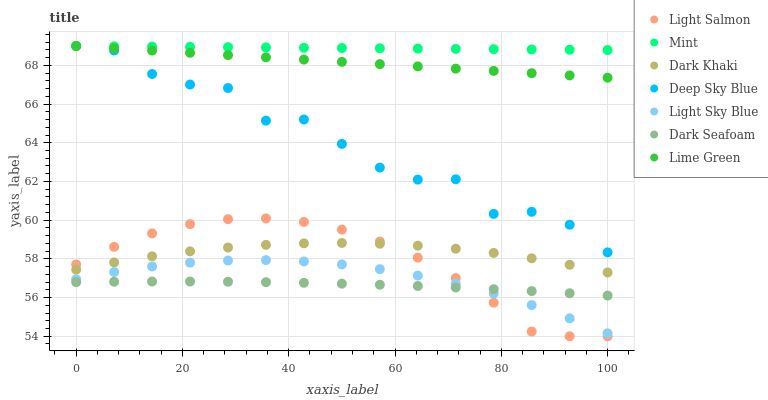Does Dark Seafoam have the minimum area under the curve?
Answer yes or no. Yes. Does Mint have the maximum area under the curve?
Answer yes or no. Yes. Does Lime Green have the minimum area under the curve?
Answer yes or no. No. Does Lime Green have the maximum area under the curve?
Answer yes or no. No. Is Mint the smoothest?
Answer yes or no. Yes. Is Deep Sky Blue the roughest?
Answer yes or no. Yes. Is Lime Green the smoothest?
Answer yes or no. No. Is Lime Green the roughest?
Answer yes or no. No. Does Light Salmon have the lowest value?
Answer yes or no. Yes. Does Lime Green have the lowest value?
Answer yes or no. No. Does Mint have the highest value?
Answer yes or no. Yes. Does Dark Khaki have the highest value?
Answer yes or no. No. Is Light Sky Blue less than Deep Sky Blue?
Answer yes or no. Yes. Is Lime Green greater than Dark Seafoam?
Answer yes or no. Yes. Does Light Salmon intersect Dark Seafoam?
Answer yes or no. Yes. Is Light Salmon less than Dark Seafoam?
Answer yes or no. No. Is Light Salmon greater than Dark Seafoam?
Answer yes or no. No. Does Light Sky Blue intersect Deep Sky Blue?
Answer yes or no. No. 